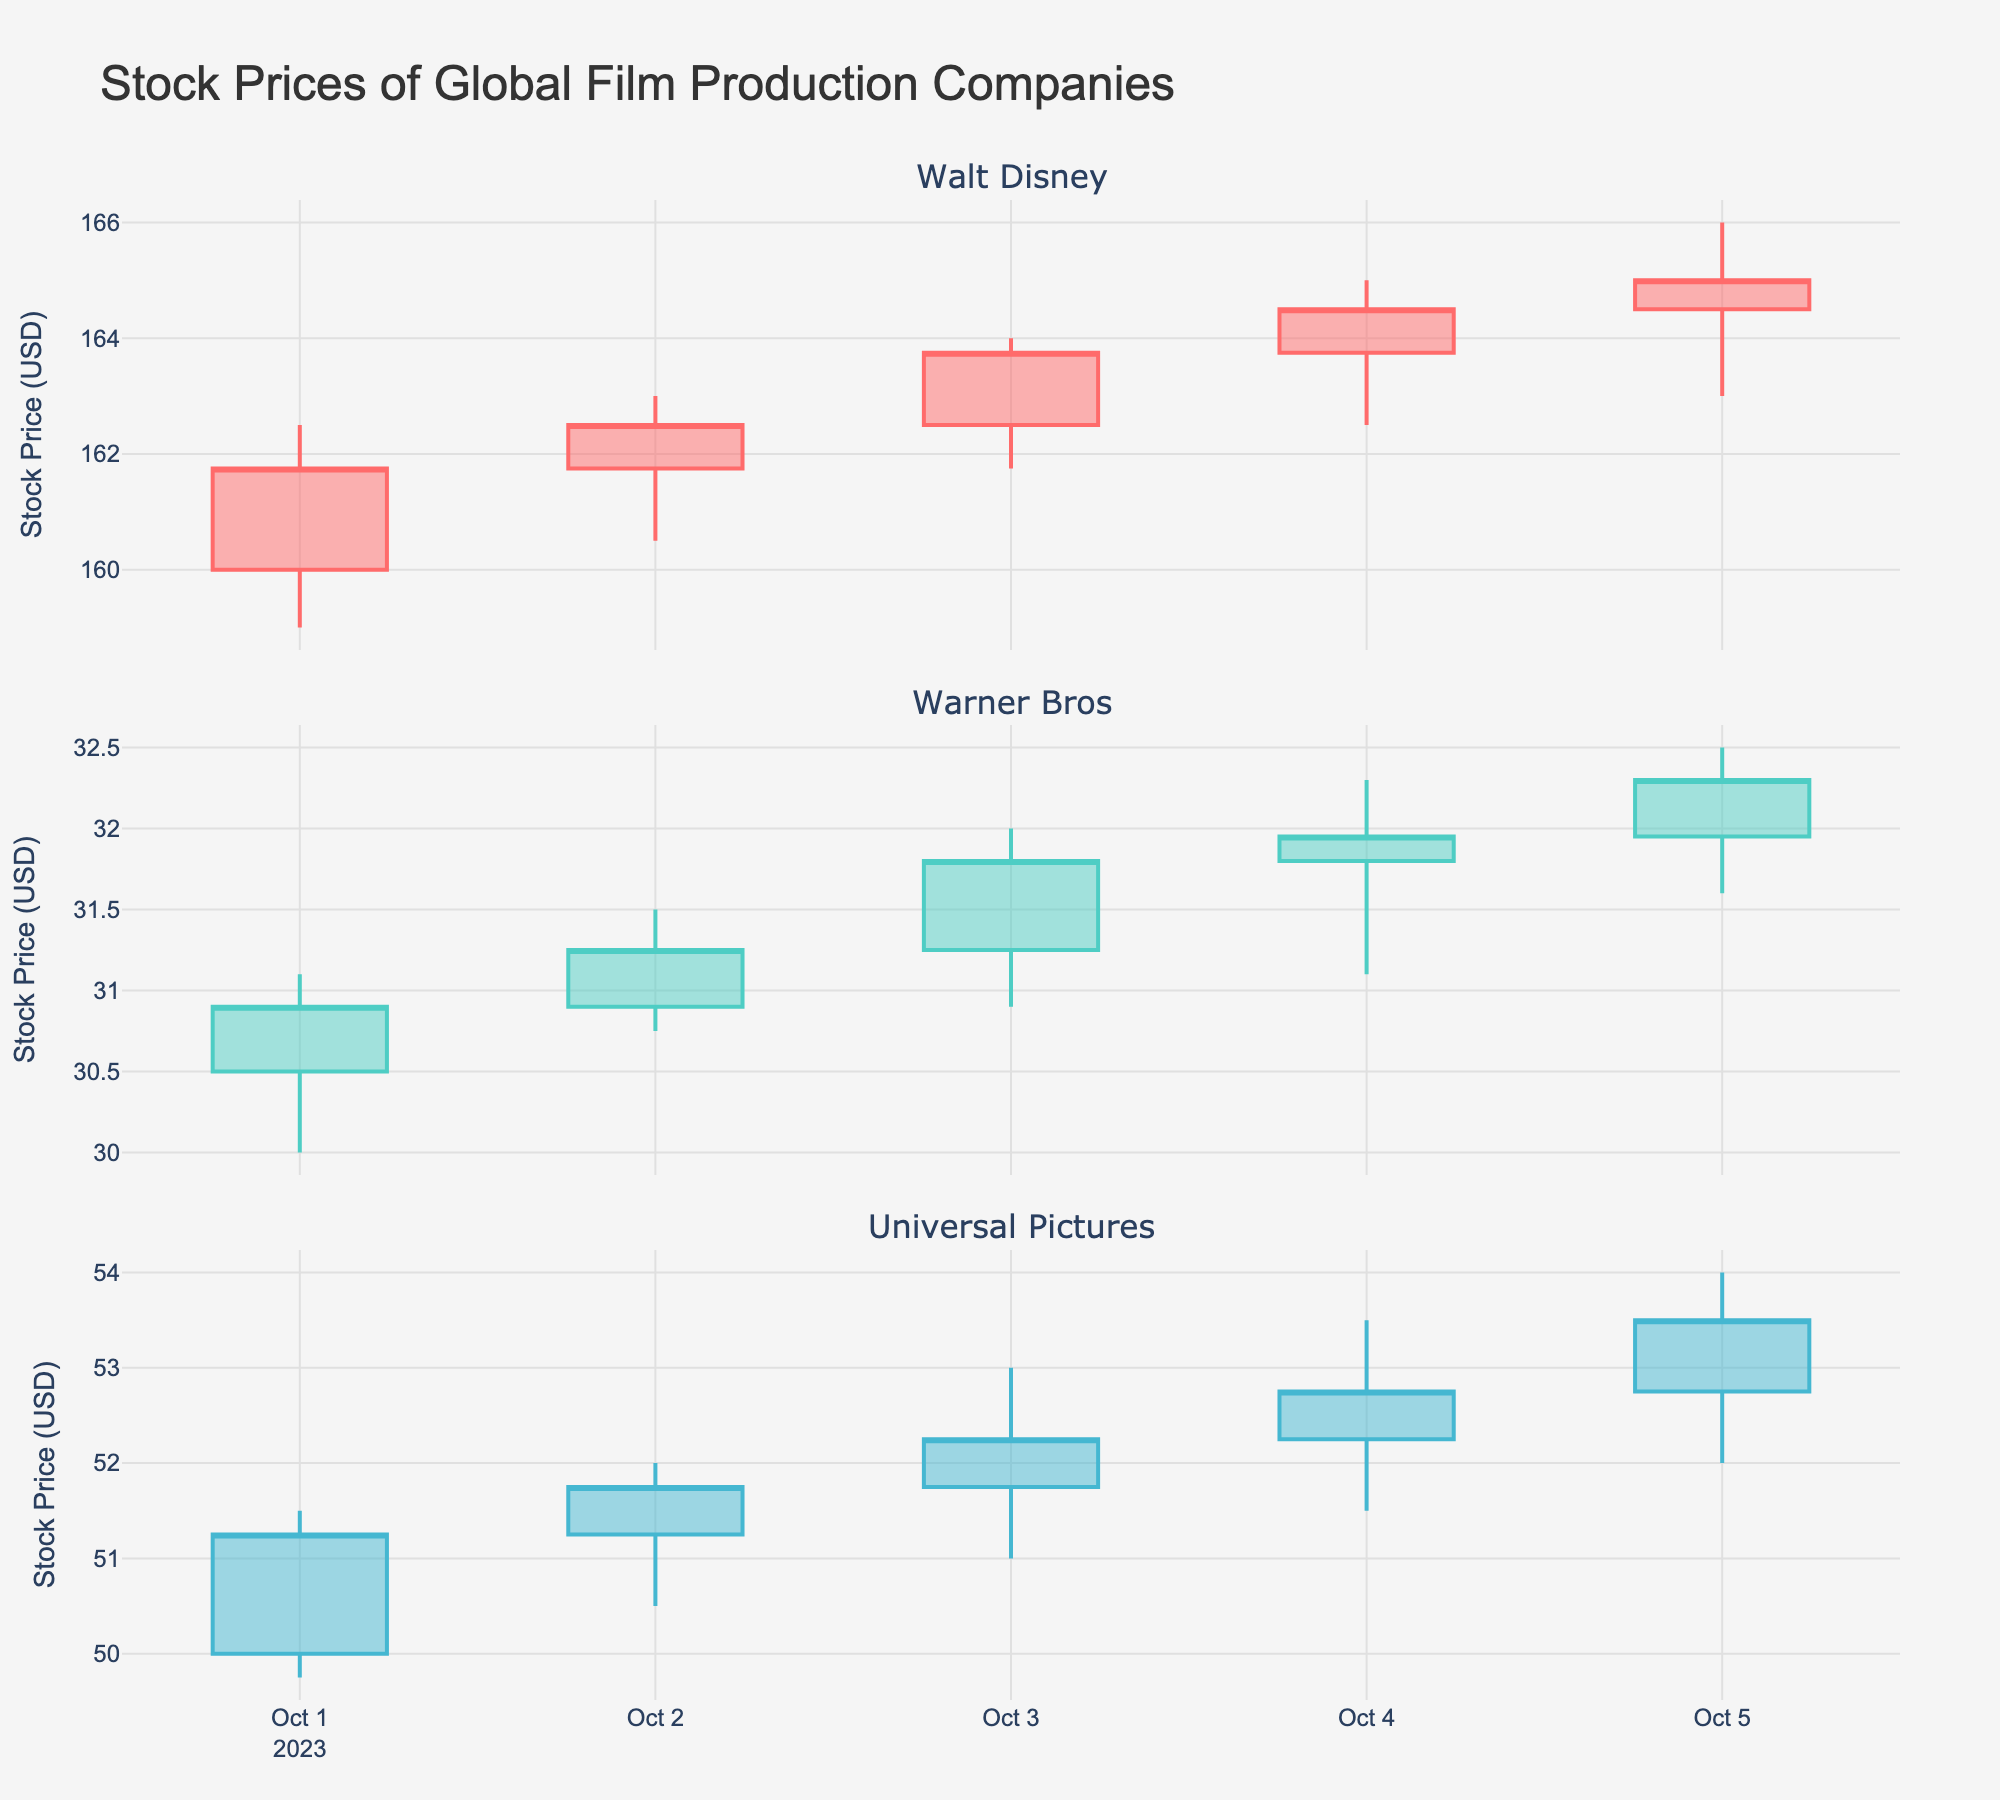which company had the highest stock opening price on October 1, 2023? Walt Disney had the highest stock opening price of 160.00 USD on October 1, 2023. To determine this, we compare the opening prices of each company on this date: Walt Disney (160.00), Warner Bros (30.50), Universal Pictures (50.00).
Answer: Walt Disney how did the closing price of Walt Disney change from October 1 to October 5, 2023? To determine the change in the closing price, we look at the closing prices on both dates. On October 1, Walt Disney's closing price was 161.75 USD, and on October 5, it was 165.00 USD. The change is 165.00 - 161.75 = 3.25 USD.
Answer: 3.25 USD which company saw the greatest increase in stock price from October 1 to October 5, 2023? Calculate the change in closing prices for each company. Walt Disney: 165.00 - 161.75 = 3.25 USD; Warner Bros: 32.30 - 30.90 = 1.40 USD; Universal Pictures: 53.50 - 51.25 = 2.25 USD. Walt Disney saw the greatest increase of 3.25 USD.
Answer: Walt Disney what was the highest stock price reached by Universal Pictures during the given period? The maximum price for Universal Pictures is found in the "High" column. By scanning all the high prices for Universal Pictures over the period, we find the highest price was 54.00 USD on October 5, 2023.
Answer: 54.00 USD compare the trading volume trend for Warner Bros and Universal Pictures on October 1, 2023. Which had higher volume and by how much? Warner Bros had a volume of 980,000 shares, and Universal Pictures had a volume of 820,000 shares on October 1, 2023. The difference is 980,000 - 820,000 = 160,000 shares.
Answer: Warner Bros, 160,000 shares what is the average closing price for Warner Bros between October 1 and October 5, 2023? Sum the closing prices for Warner Bros over these dates: 30.90, 31.25, 31.80, 31.95, 32.30. The total is 30.90 + 31.25 + 31.80 + 31.95 + 32.30 = 158.20. The average is 158.20 / 5 = 31.64 USD.
Answer: 31.64 USD which day had the lowest closing price for Warner Bros during the given period? By checking the closing prices for each date, the lowest closing price for Warner Bros is 30.90 USD on October 1, 2023.
Answer: October 1, 2023 how many times did Walt Disney's stock closing price increase consecutively during the period? Walt Disney had consecutive increases from October 1 to October 5, 2023. The sequence was 161.75, 162.50, 163.75, 164.50, 165.00, showing 4 consecutive days of increases.
Answer: 4 times what was the overall trend of Universal Pictures' stock price from October 1 to October 5, 2023? Look at the closing prices: starting at 51.25 on October 1 and ending at 53.50 on October 5. The trend shows an increase from 51.25 to 53.50 over the 5 days.
Answer: Increasing 